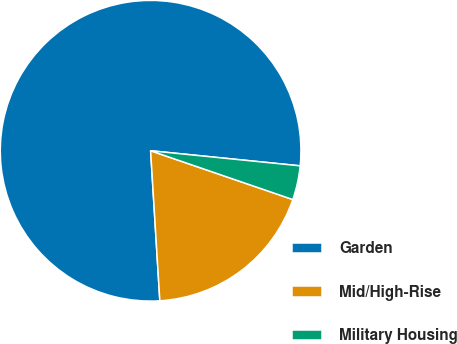Convert chart to OTSL. <chart><loc_0><loc_0><loc_500><loc_500><pie_chart><fcel>Garden<fcel>Mid/High-Rise<fcel>Military Housing<nl><fcel>77.58%<fcel>18.76%<fcel>3.66%<nl></chart> 